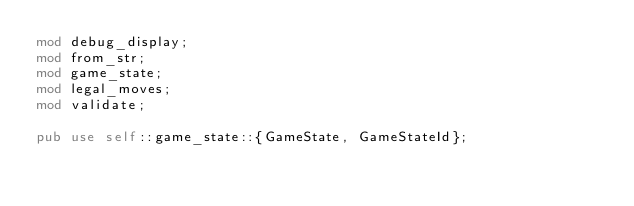<code> <loc_0><loc_0><loc_500><loc_500><_Rust_>mod debug_display;
mod from_str;
mod game_state;
mod legal_moves;
mod validate;

pub use self::game_state::{GameState, GameStateId};
</code> 